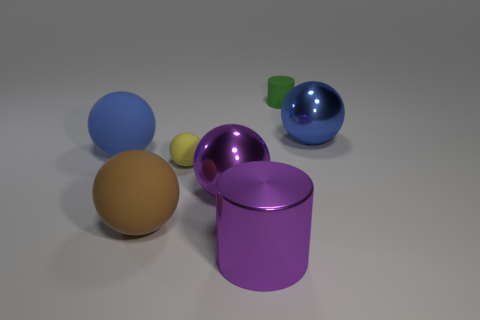Subtract all small rubber balls. How many balls are left? 4 Add 1 rubber things. How many objects exist? 8 Subtract all balls. How many objects are left? 2 Subtract 1 cylinders. How many cylinders are left? 1 Subtract all gray balls. How many red cylinders are left? 0 Subtract all big purple objects. Subtract all big shiny cubes. How many objects are left? 5 Add 4 big purple balls. How many big purple balls are left? 5 Add 7 big brown rubber cylinders. How many big brown rubber cylinders exist? 7 Subtract all purple cylinders. How many cylinders are left? 1 Subtract 0 green balls. How many objects are left? 7 